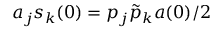Convert formula to latex. <formula><loc_0><loc_0><loc_500><loc_500>a _ { j } s _ { k } ( 0 ) = p _ { j } \tilde { p } _ { k } a ( 0 ) / 2</formula> 